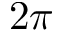Convert formula to latex. <formula><loc_0><loc_0><loc_500><loc_500>2 \pi</formula> 